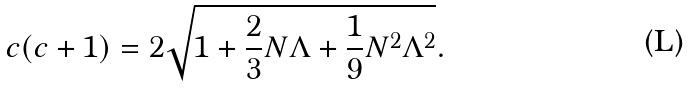Convert formula to latex. <formula><loc_0><loc_0><loc_500><loc_500>c ( c + 1 ) = 2 \sqrt { 1 + \frac { 2 } { 3 } N \Lambda + \frac { 1 } { 9 } N ^ { 2 } \Lambda ^ { 2 } } .</formula> 